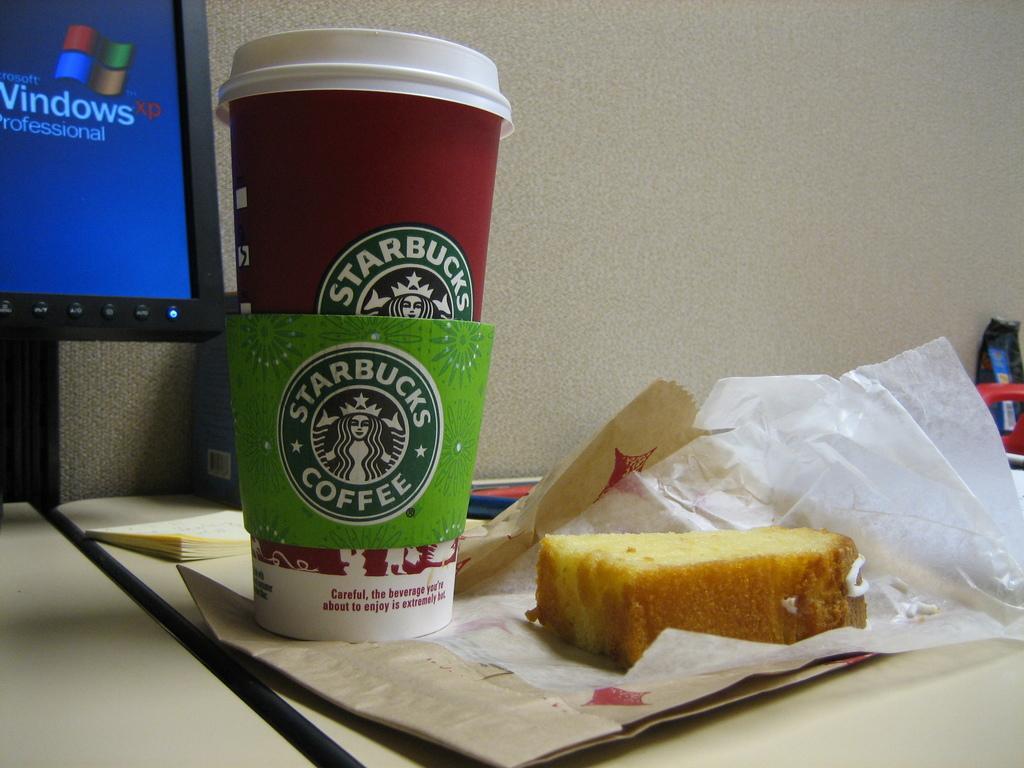Describe this image in one or two sentences. In this image I can see the food which is in brown color and the food is on the paper. I can also see few glasses, a system on the table and I can see cream color background. 